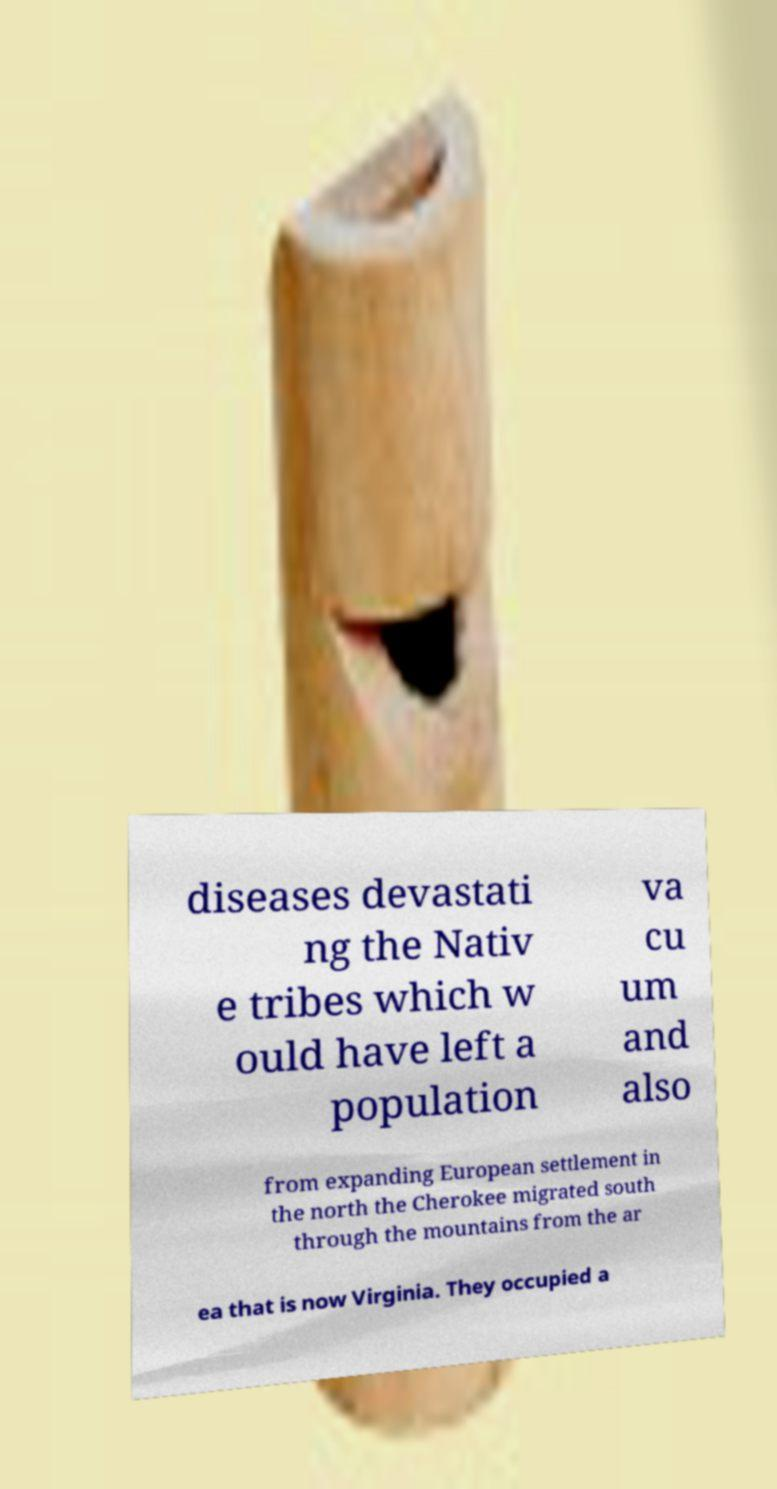Can you read and provide the text displayed in the image?This photo seems to have some interesting text. Can you extract and type it out for me? diseases devastati ng the Nativ e tribes which w ould have left a population va cu um and also from expanding European settlement in the north the Cherokee migrated south through the mountains from the ar ea that is now Virginia. They occupied a 